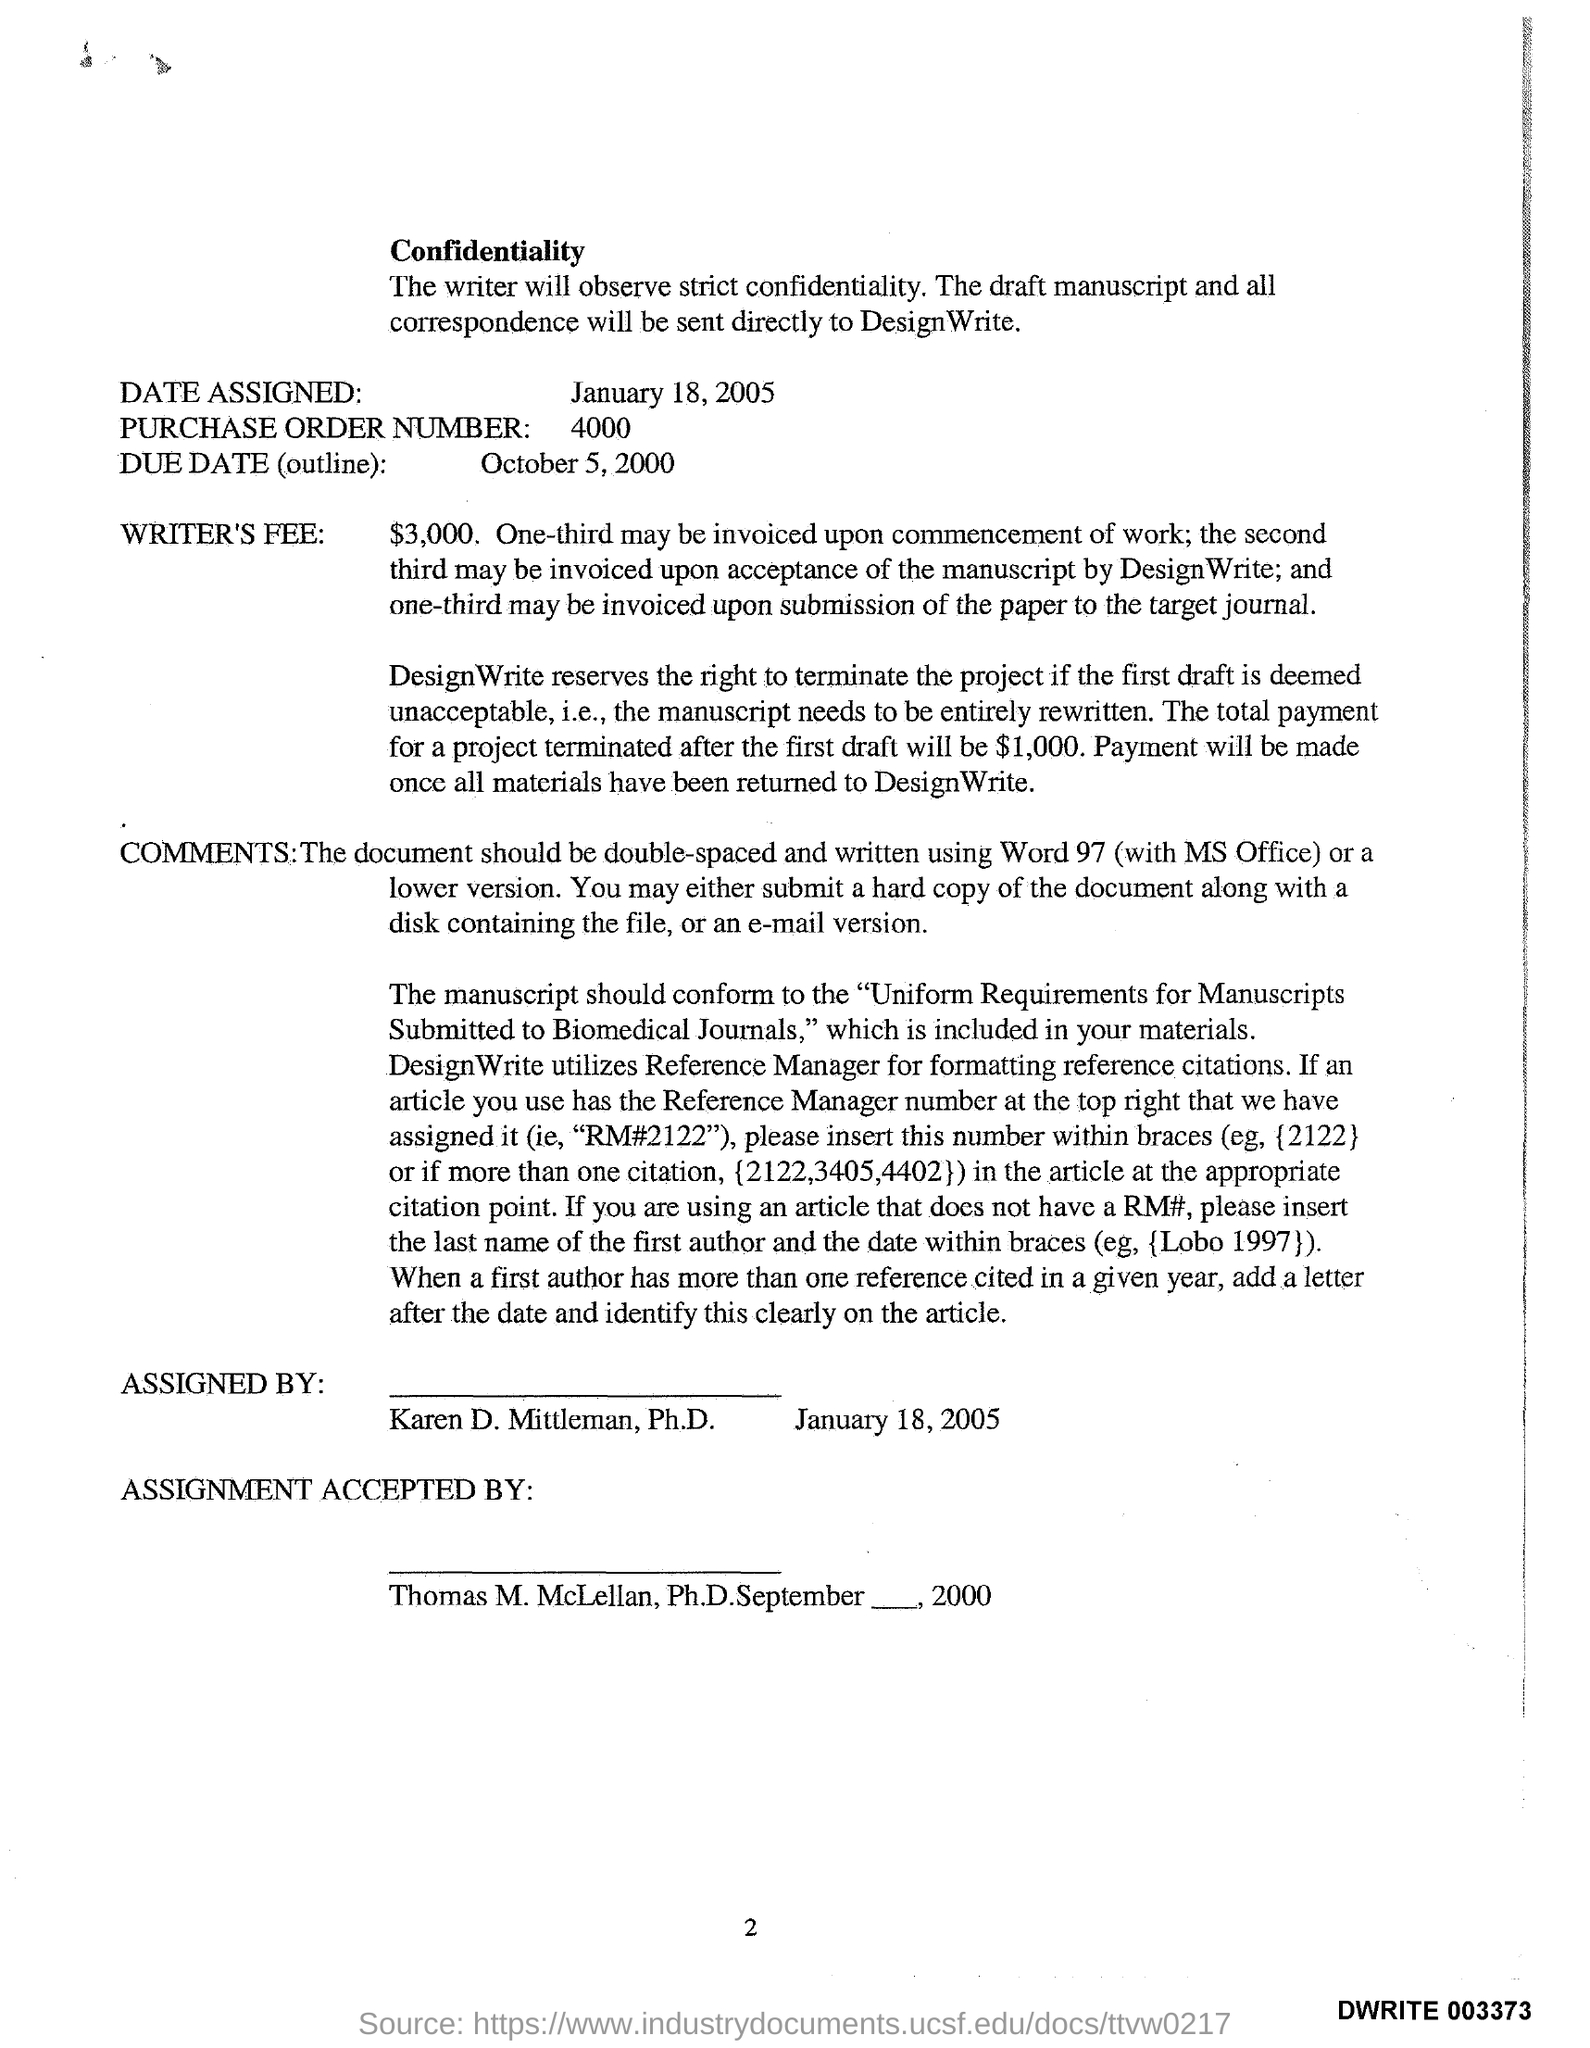What is the Date Assigned as per the document?
Offer a very short reply. January 18, 2005. What is the Purchase Order Number given in the document?
Offer a very short reply. 4000. What is the Due Date(outline) mentioned in the document?
Your response must be concise. OCTOBER 5, 2000. How much is the Writer's Fee?
Your response must be concise. $3,000. What is the page no mentioned in this document?
Offer a terse response. 2. 